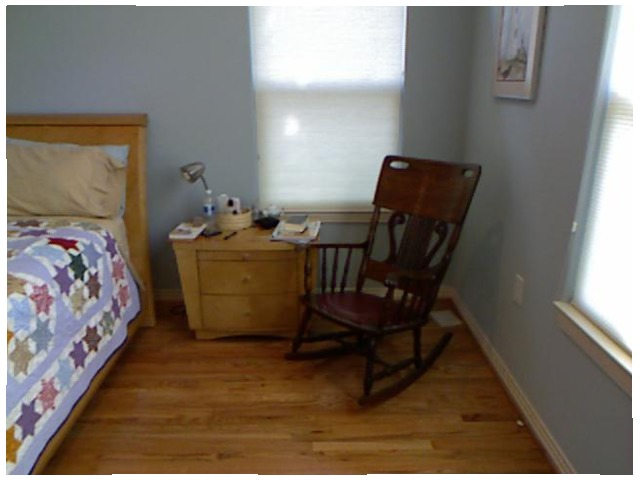<image>
Can you confirm if the chair is under the bed? No. The chair is not positioned under the bed. The vertical relationship between these objects is different. Is the table lamp on the side table? Yes. Looking at the image, I can see the table lamp is positioned on top of the side table, with the side table providing support. Is the bed above the land? No. The bed is not positioned above the land. The vertical arrangement shows a different relationship. 